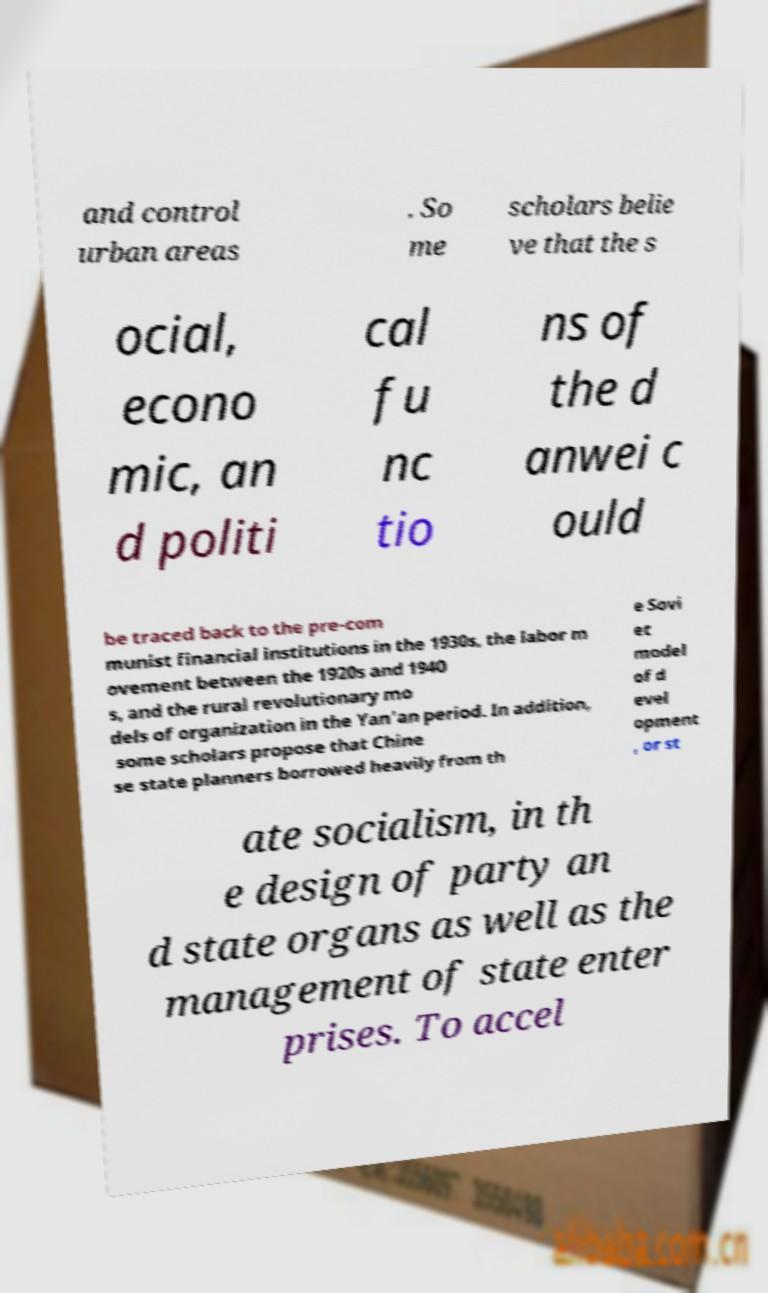I need the written content from this picture converted into text. Can you do that? and control urban areas . So me scholars belie ve that the s ocial, econo mic, an d politi cal fu nc tio ns of the d anwei c ould be traced back to the pre-com munist financial institutions in the 1930s, the labor m ovement between the 1920s and 1940 s, and the rural revolutionary mo dels of organization in the Yan'an period. In addition, some scholars propose that Chine se state planners borrowed heavily from th e Sovi et model of d evel opment , or st ate socialism, in th e design of party an d state organs as well as the management of state enter prises. To accel 